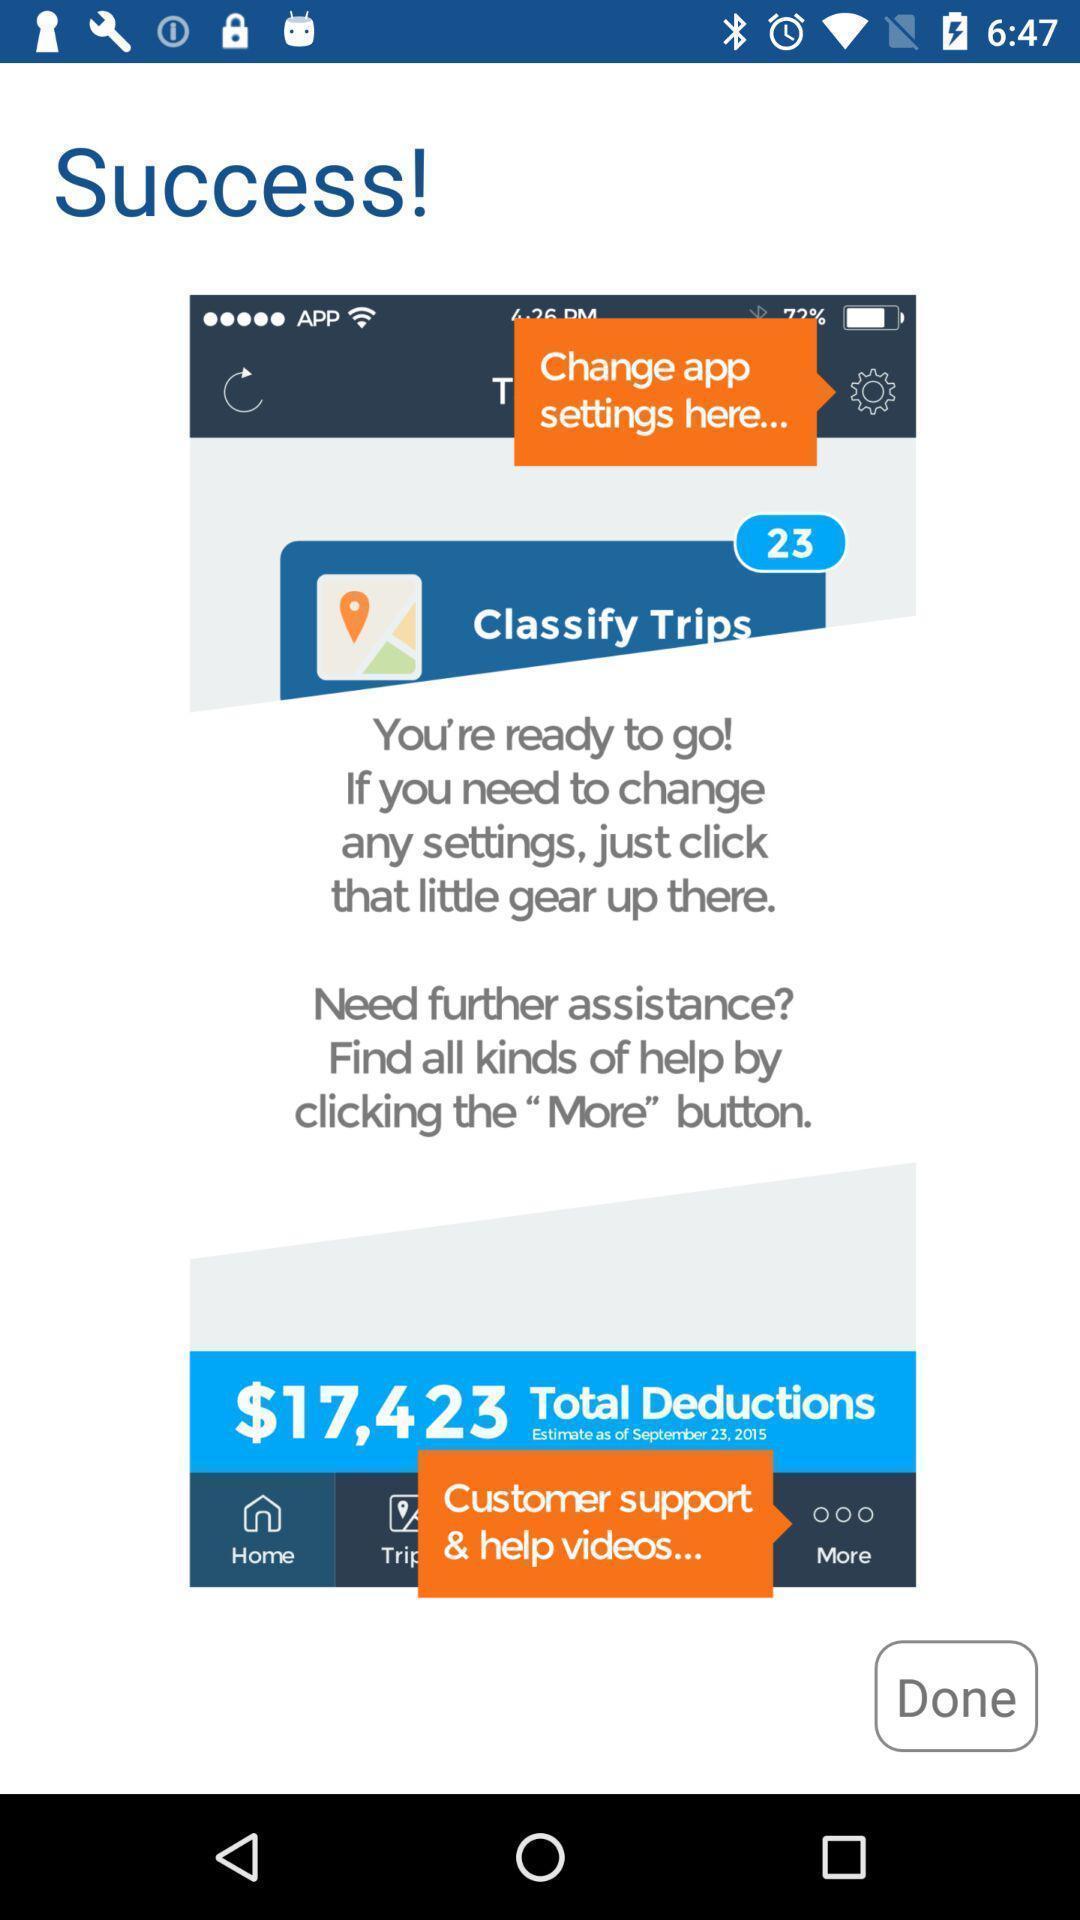Give me a narrative description of this picture. Screen displaying the guide for using an app. 